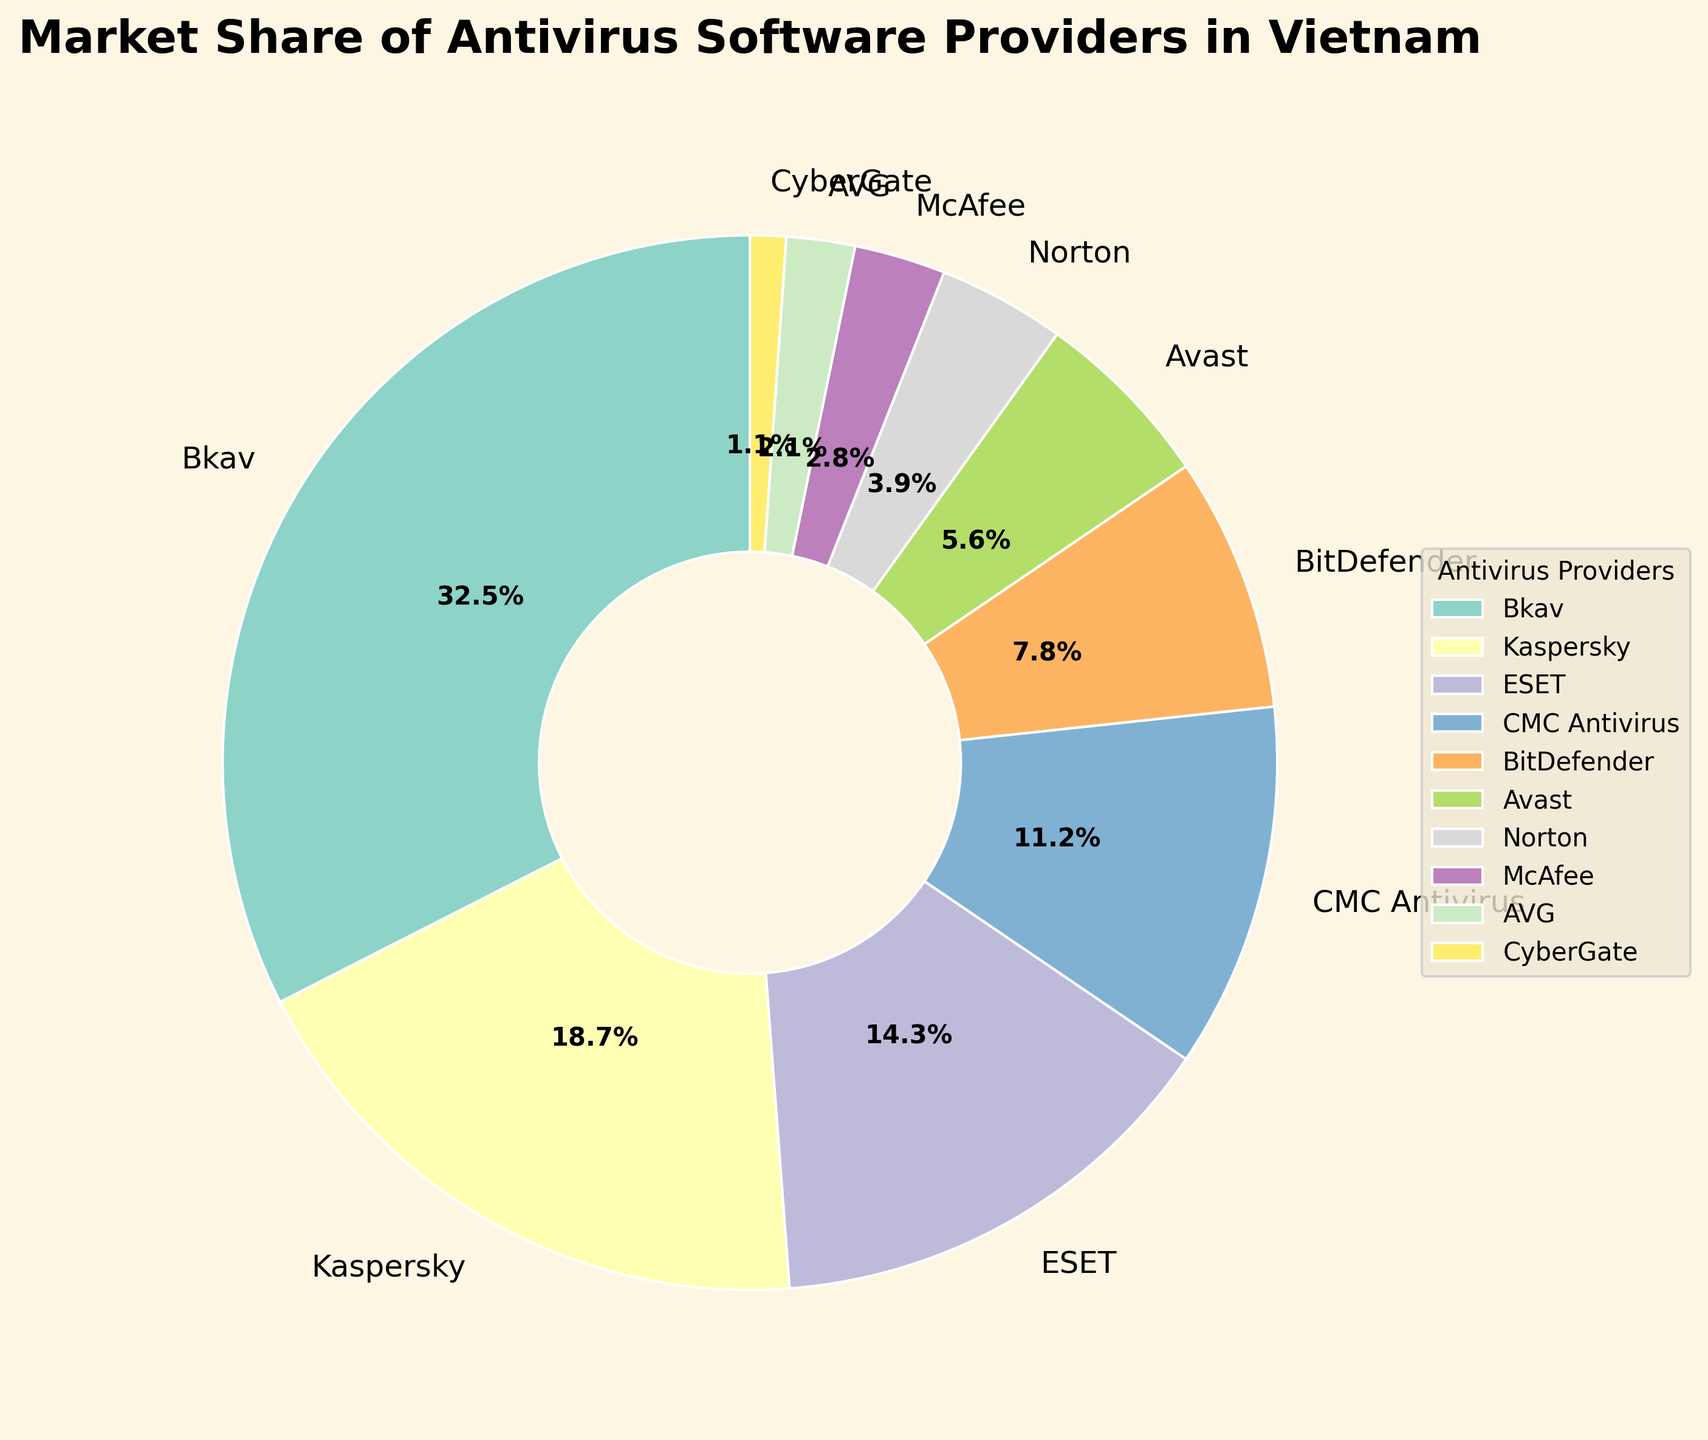What's the market share of the top antivirus provider in Vietnam? The figure shows that Bkav is the top antivirus provider in Vietnam. Looking at the pie chart, Bkav has the largest slice labeled with 32.5%.
Answer: 32.5% Which antivirus provider has the second-largest market share and what is it? By inspecting the size and labels of the pie chart's slices, Kaspersky is the provider with the second largest market share at 18.7%.
Answer: Kaspersky, 18.7% What is the combined market share of Bkav and Kaspersky? Sum the market share percentages labeled in the pie chart for Bkav (32.5%) and Kaspersky (18.7%): 32.5 + 18.7 = 51.2%.
Answer: 51.2% How does the market share of BitDefender compare to that of ESET? From the pie chart, BitDefender has a market share of 7.8% while ESET has a market share of 14.3%. BitDefender's market share is less than ESET's.
Answer: Less than Which antivirus provider has the smallest market share in Vietnam? The smallest slice in the pie chart corresponds to CyberGate, which has a market share of 1.1%.
Answer: CyberGate What's the total market share percentage of all providers except Bkav and Kaspersky? Subtract the combined market share of Bkav and Kaspersky from 100%: 100 - (32.5 + 18.7) = 48.8%.
Answer: 48.8% How does the market share of CMC Antivirus, BitDefender, and Avast combined compare to Bkav's market share? Sum the market shares of CMC Antivirus (11.2%), BitDefender (7.8%), and Avast (5.6%) then compare it to Bkav's share: 11.2 + 7.8 + 5.6 = 24.6%; 24.6% < 32.5%.
Answer: Less than Bkav's Is the market share of Norton greater than AVG's and McAfee's combined? Compare the market share of Norton (3.9%) with the sum of AVG (2.1%) and McAfee (2.8%): 3.9 > (2.1 + 2.8 = 4.9%). Norton has a smaller share.
Answer: No Which slice in the pie chart is colored green? The color green in the pie chart is used to represent ESET, which has a market share of 14.3%.
Answer: ESET What's the average market share of the antivirus providers ESET, BitDefender, and McAfee? Calculate the average by summing the market shares and dividing by the number of providers: (14.3 + 7.8 + 2.8) / 3 = 8.3%.
Answer: 8.3% 